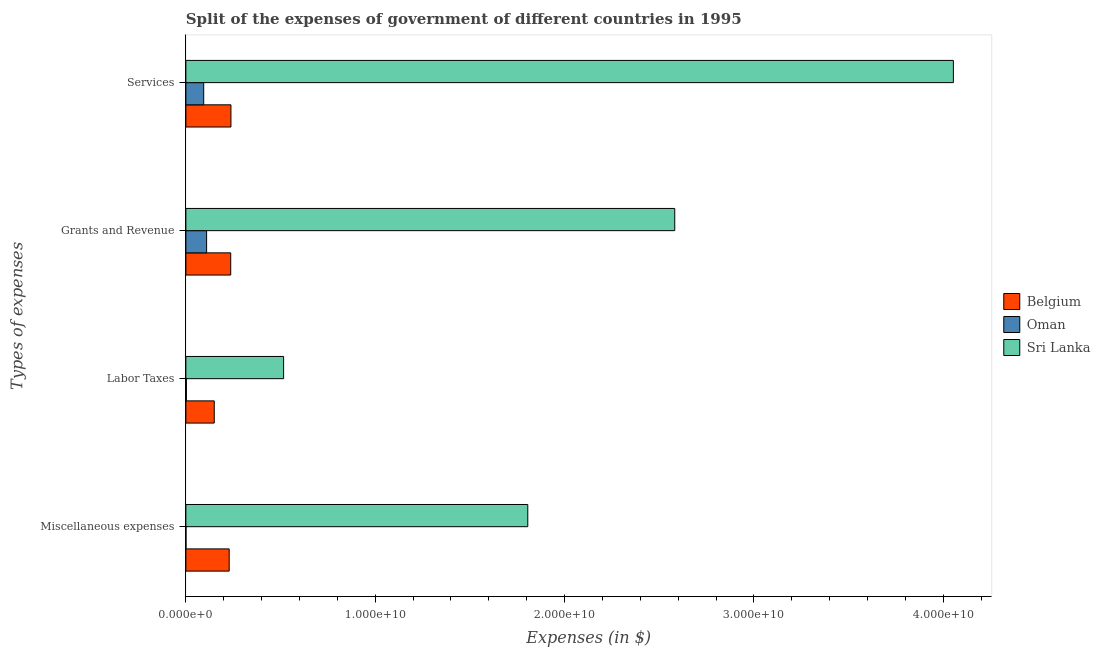How many bars are there on the 3rd tick from the bottom?
Give a very brief answer. 3. What is the label of the 1st group of bars from the top?
Your response must be concise. Services. What is the amount spent on grants and revenue in Sri Lanka?
Your answer should be very brief. 2.58e+1. Across all countries, what is the maximum amount spent on services?
Your answer should be very brief. 4.05e+1. Across all countries, what is the minimum amount spent on grants and revenue?
Provide a short and direct response. 1.10e+09. In which country was the amount spent on services maximum?
Ensure brevity in your answer.  Sri Lanka. In which country was the amount spent on labor taxes minimum?
Your answer should be compact. Oman. What is the total amount spent on labor taxes in the graph?
Provide a succinct answer. 6.69e+09. What is the difference between the amount spent on grants and revenue in Sri Lanka and that in Belgium?
Keep it short and to the point. 2.35e+1. What is the difference between the amount spent on grants and revenue in Oman and the amount spent on miscellaneous expenses in Belgium?
Give a very brief answer. -1.19e+09. What is the average amount spent on services per country?
Your answer should be compact. 1.46e+1. What is the difference between the amount spent on services and amount spent on miscellaneous expenses in Oman?
Give a very brief answer. 9.36e+08. In how many countries, is the amount spent on miscellaneous expenses greater than 2000000000 $?
Offer a very short reply. 2. What is the ratio of the amount spent on services in Belgium to that in Sri Lanka?
Provide a succinct answer. 0.06. Is the amount spent on services in Oman less than that in Sri Lanka?
Give a very brief answer. Yes. Is the difference between the amount spent on grants and revenue in Sri Lanka and Belgium greater than the difference between the amount spent on labor taxes in Sri Lanka and Belgium?
Your response must be concise. Yes. What is the difference between the highest and the second highest amount spent on services?
Your response must be concise. 3.82e+1. What is the difference between the highest and the lowest amount spent on miscellaneous expenses?
Make the answer very short. 1.81e+1. Is it the case that in every country, the sum of the amount spent on labor taxes and amount spent on services is greater than the sum of amount spent on miscellaneous expenses and amount spent on grants and revenue?
Offer a very short reply. No. What does the 1st bar from the top in Grants and Revenue represents?
Ensure brevity in your answer.  Sri Lanka. What does the 3rd bar from the bottom in Grants and Revenue represents?
Offer a terse response. Sri Lanka. Is it the case that in every country, the sum of the amount spent on miscellaneous expenses and amount spent on labor taxes is greater than the amount spent on grants and revenue?
Your answer should be compact. No. How many countries are there in the graph?
Offer a terse response. 3. What is the difference between two consecutive major ticks on the X-axis?
Provide a succinct answer. 1.00e+1. What is the title of the graph?
Give a very brief answer. Split of the expenses of government of different countries in 1995. What is the label or title of the X-axis?
Ensure brevity in your answer.  Expenses (in $). What is the label or title of the Y-axis?
Your answer should be compact. Types of expenses. What is the Expenses (in $) of Belgium in Miscellaneous expenses?
Offer a terse response. 2.29e+09. What is the Expenses (in $) in Oman in Miscellaneous expenses?
Offer a terse response. 5.40e+06. What is the Expenses (in $) in Sri Lanka in Miscellaneous expenses?
Offer a terse response. 1.81e+1. What is the Expenses (in $) in Belgium in Labor Taxes?
Provide a short and direct response. 1.50e+09. What is the Expenses (in $) in Oman in Labor Taxes?
Keep it short and to the point. 2.69e+07. What is the Expenses (in $) of Sri Lanka in Labor Taxes?
Your answer should be compact. 5.16e+09. What is the Expenses (in $) of Belgium in Grants and Revenue?
Your answer should be very brief. 2.37e+09. What is the Expenses (in $) in Oman in Grants and Revenue?
Your response must be concise. 1.10e+09. What is the Expenses (in $) of Sri Lanka in Grants and Revenue?
Keep it short and to the point. 2.58e+1. What is the Expenses (in $) of Belgium in Services?
Keep it short and to the point. 2.38e+09. What is the Expenses (in $) in Oman in Services?
Ensure brevity in your answer.  9.41e+08. What is the Expenses (in $) in Sri Lanka in Services?
Offer a very short reply. 4.05e+1. Across all Types of expenses, what is the maximum Expenses (in $) in Belgium?
Offer a terse response. 2.38e+09. Across all Types of expenses, what is the maximum Expenses (in $) of Oman?
Give a very brief answer. 1.10e+09. Across all Types of expenses, what is the maximum Expenses (in $) of Sri Lanka?
Keep it short and to the point. 4.05e+1. Across all Types of expenses, what is the minimum Expenses (in $) of Belgium?
Your response must be concise. 1.50e+09. Across all Types of expenses, what is the minimum Expenses (in $) in Oman?
Your answer should be compact. 5.40e+06. Across all Types of expenses, what is the minimum Expenses (in $) in Sri Lanka?
Keep it short and to the point. 5.16e+09. What is the total Expenses (in $) in Belgium in the graph?
Offer a terse response. 8.53e+09. What is the total Expenses (in $) of Oman in the graph?
Your answer should be compact. 2.07e+09. What is the total Expenses (in $) of Sri Lanka in the graph?
Make the answer very short. 8.96e+1. What is the difference between the Expenses (in $) of Belgium in Miscellaneous expenses and that in Labor Taxes?
Keep it short and to the point. 7.88e+08. What is the difference between the Expenses (in $) in Oman in Miscellaneous expenses and that in Labor Taxes?
Your answer should be very brief. -2.15e+07. What is the difference between the Expenses (in $) in Sri Lanka in Miscellaneous expenses and that in Labor Taxes?
Ensure brevity in your answer.  1.29e+1. What is the difference between the Expenses (in $) in Belgium in Miscellaneous expenses and that in Grants and Revenue?
Your answer should be compact. -8.12e+07. What is the difference between the Expenses (in $) of Oman in Miscellaneous expenses and that in Grants and Revenue?
Make the answer very short. -1.09e+09. What is the difference between the Expenses (in $) in Sri Lanka in Miscellaneous expenses and that in Grants and Revenue?
Provide a short and direct response. -7.76e+09. What is the difference between the Expenses (in $) in Belgium in Miscellaneous expenses and that in Services?
Give a very brief answer. -9.22e+07. What is the difference between the Expenses (in $) in Oman in Miscellaneous expenses and that in Services?
Ensure brevity in your answer.  -9.36e+08. What is the difference between the Expenses (in $) of Sri Lanka in Miscellaneous expenses and that in Services?
Provide a succinct answer. -2.25e+1. What is the difference between the Expenses (in $) in Belgium in Labor Taxes and that in Grants and Revenue?
Your answer should be compact. -8.70e+08. What is the difference between the Expenses (in $) in Oman in Labor Taxes and that in Grants and Revenue?
Make the answer very short. -1.07e+09. What is the difference between the Expenses (in $) in Sri Lanka in Labor Taxes and that in Grants and Revenue?
Your answer should be compact. -2.07e+1. What is the difference between the Expenses (in $) in Belgium in Labor Taxes and that in Services?
Provide a succinct answer. -8.81e+08. What is the difference between the Expenses (in $) in Oman in Labor Taxes and that in Services?
Provide a short and direct response. -9.14e+08. What is the difference between the Expenses (in $) in Sri Lanka in Labor Taxes and that in Services?
Your answer should be compact. -3.54e+1. What is the difference between the Expenses (in $) of Belgium in Grants and Revenue and that in Services?
Your answer should be compact. -1.10e+07. What is the difference between the Expenses (in $) of Oman in Grants and Revenue and that in Services?
Give a very brief answer. 1.54e+08. What is the difference between the Expenses (in $) of Sri Lanka in Grants and Revenue and that in Services?
Offer a very short reply. -1.47e+1. What is the difference between the Expenses (in $) in Belgium in Miscellaneous expenses and the Expenses (in $) in Oman in Labor Taxes?
Make the answer very short. 2.26e+09. What is the difference between the Expenses (in $) in Belgium in Miscellaneous expenses and the Expenses (in $) in Sri Lanka in Labor Taxes?
Your answer should be compact. -2.87e+09. What is the difference between the Expenses (in $) of Oman in Miscellaneous expenses and the Expenses (in $) of Sri Lanka in Labor Taxes?
Provide a short and direct response. -5.16e+09. What is the difference between the Expenses (in $) in Belgium in Miscellaneous expenses and the Expenses (in $) in Oman in Grants and Revenue?
Your response must be concise. 1.19e+09. What is the difference between the Expenses (in $) of Belgium in Miscellaneous expenses and the Expenses (in $) of Sri Lanka in Grants and Revenue?
Offer a terse response. -2.35e+1. What is the difference between the Expenses (in $) of Oman in Miscellaneous expenses and the Expenses (in $) of Sri Lanka in Grants and Revenue?
Keep it short and to the point. -2.58e+1. What is the difference between the Expenses (in $) of Belgium in Miscellaneous expenses and the Expenses (in $) of Oman in Services?
Make the answer very short. 1.35e+09. What is the difference between the Expenses (in $) of Belgium in Miscellaneous expenses and the Expenses (in $) of Sri Lanka in Services?
Keep it short and to the point. -3.83e+1. What is the difference between the Expenses (in $) of Oman in Miscellaneous expenses and the Expenses (in $) of Sri Lanka in Services?
Offer a terse response. -4.05e+1. What is the difference between the Expenses (in $) in Belgium in Labor Taxes and the Expenses (in $) in Oman in Grants and Revenue?
Offer a very short reply. 4.04e+08. What is the difference between the Expenses (in $) in Belgium in Labor Taxes and the Expenses (in $) in Sri Lanka in Grants and Revenue?
Offer a very short reply. -2.43e+1. What is the difference between the Expenses (in $) in Oman in Labor Taxes and the Expenses (in $) in Sri Lanka in Grants and Revenue?
Provide a short and direct response. -2.58e+1. What is the difference between the Expenses (in $) in Belgium in Labor Taxes and the Expenses (in $) in Oman in Services?
Your response must be concise. 5.58e+08. What is the difference between the Expenses (in $) of Belgium in Labor Taxes and the Expenses (in $) of Sri Lanka in Services?
Provide a succinct answer. -3.90e+1. What is the difference between the Expenses (in $) of Oman in Labor Taxes and the Expenses (in $) of Sri Lanka in Services?
Your answer should be compact. -4.05e+1. What is the difference between the Expenses (in $) of Belgium in Grants and Revenue and the Expenses (in $) of Oman in Services?
Your answer should be compact. 1.43e+09. What is the difference between the Expenses (in $) of Belgium in Grants and Revenue and the Expenses (in $) of Sri Lanka in Services?
Your response must be concise. -3.82e+1. What is the difference between the Expenses (in $) in Oman in Grants and Revenue and the Expenses (in $) in Sri Lanka in Services?
Offer a terse response. -3.94e+1. What is the average Expenses (in $) in Belgium per Types of expenses?
Your answer should be very brief. 2.13e+09. What is the average Expenses (in $) of Oman per Types of expenses?
Keep it short and to the point. 5.17e+08. What is the average Expenses (in $) of Sri Lanka per Types of expenses?
Make the answer very short. 2.24e+1. What is the difference between the Expenses (in $) in Belgium and Expenses (in $) in Oman in Miscellaneous expenses?
Your response must be concise. 2.28e+09. What is the difference between the Expenses (in $) of Belgium and Expenses (in $) of Sri Lanka in Miscellaneous expenses?
Offer a very short reply. -1.58e+1. What is the difference between the Expenses (in $) in Oman and Expenses (in $) in Sri Lanka in Miscellaneous expenses?
Keep it short and to the point. -1.81e+1. What is the difference between the Expenses (in $) in Belgium and Expenses (in $) in Oman in Labor Taxes?
Offer a terse response. 1.47e+09. What is the difference between the Expenses (in $) in Belgium and Expenses (in $) in Sri Lanka in Labor Taxes?
Offer a terse response. -3.66e+09. What is the difference between the Expenses (in $) in Oman and Expenses (in $) in Sri Lanka in Labor Taxes?
Keep it short and to the point. -5.14e+09. What is the difference between the Expenses (in $) in Belgium and Expenses (in $) in Oman in Grants and Revenue?
Ensure brevity in your answer.  1.27e+09. What is the difference between the Expenses (in $) of Belgium and Expenses (in $) of Sri Lanka in Grants and Revenue?
Offer a terse response. -2.35e+1. What is the difference between the Expenses (in $) in Oman and Expenses (in $) in Sri Lanka in Grants and Revenue?
Your response must be concise. -2.47e+1. What is the difference between the Expenses (in $) in Belgium and Expenses (in $) in Oman in Services?
Your response must be concise. 1.44e+09. What is the difference between the Expenses (in $) in Belgium and Expenses (in $) in Sri Lanka in Services?
Give a very brief answer. -3.82e+1. What is the difference between the Expenses (in $) in Oman and Expenses (in $) in Sri Lanka in Services?
Provide a succinct answer. -3.96e+1. What is the ratio of the Expenses (in $) of Belgium in Miscellaneous expenses to that in Labor Taxes?
Offer a very short reply. 1.53. What is the ratio of the Expenses (in $) of Oman in Miscellaneous expenses to that in Labor Taxes?
Offer a terse response. 0.2. What is the ratio of the Expenses (in $) in Sri Lanka in Miscellaneous expenses to that in Labor Taxes?
Ensure brevity in your answer.  3.5. What is the ratio of the Expenses (in $) of Belgium in Miscellaneous expenses to that in Grants and Revenue?
Provide a succinct answer. 0.97. What is the ratio of the Expenses (in $) of Oman in Miscellaneous expenses to that in Grants and Revenue?
Provide a short and direct response. 0. What is the ratio of the Expenses (in $) in Sri Lanka in Miscellaneous expenses to that in Grants and Revenue?
Provide a short and direct response. 0.7. What is the ratio of the Expenses (in $) of Belgium in Miscellaneous expenses to that in Services?
Give a very brief answer. 0.96. What is the ratio of the Expenses (in $) in Oman in Miscellaneous expenses to that in Services?
Make the answer very short. 0.01. What is the ratio of the Expenses (in $) of Sri Lanka in Miscellaneous expenses to that in Services?
Offer a very short reply. 0.45. What is the ratio of the Expenses (in $) in Belgium in Labor Taxes to that in Grants and Revenue?
Make the answer very short. 0.63. What is the ratio of the Expenses (in $) in Oman in Labor Taxes to that in Grants and Revenue?
Your response must be concise. 0.02. What is the ratio of the Expenses (in $) in Sri Lanka in Labor Taxes to that in Grants and Revenue?
Offer a terse response. 0.2. What is the ratio of the Expenses (in $) of Belgium in Labor Taxes to that in Services?
Keep it short and to the point. 0.63. What is the ratio of the Expenses (in $) of Oman in Labor Taxes to that in Services?
Offer a very short reply. 0.03. What is the ratio of the Expenses (in $) of Sri Lanka in Labor Taxes to that in Services?
Your response must be concise. 0.13. What is the ratio of the Expenses (in $) in Oman in Grants and Revenue to that in Services?
Your response must be concise. 1.16. What is the ratio of the Expenses (in $) of Sri Lanka in Grants and Revenue to that in Services?
Ensure brevity in your answer.  0.64. What is the difference between the highest and the second highest Expenses (in $) of Belgium?
Make the answer very short. 1.10e+07. What is the difference between the highest and the second highest Expenses (in $) of Oman?
Provide a succinct answer. 1.54e+08. What is the difference between the highest and the second highest Expenses (in $) in Sri Lanka?
Your answer should be very brief. 1.47e+1. What is the difference between the highest and the lowest Expenses (in $) of Belgium?
Offer a terse response. 8.81e+08. What is the difference between the highest and the lowest Expenses (in $) of Oman?
Give a very brief answer. 1.09e+09. What is the difference between the highest and the lowest Expenses (in $) in Sri Lanka?
Provide a short and direct response. 3.54e+1. 